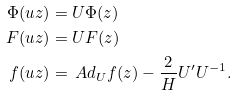<formula> <loc_0><loc_0><loc_500><loc_500>\Phi ( u z ) & = U \Phi ( z ) \\ F ( u z ) & = U F ( z ) \\ f ( u z ) & = \ A d _ { U } f ( z ) - \frac { 2 } { H } U ^ { \prime } U ^ { - 1 } .</formula> 